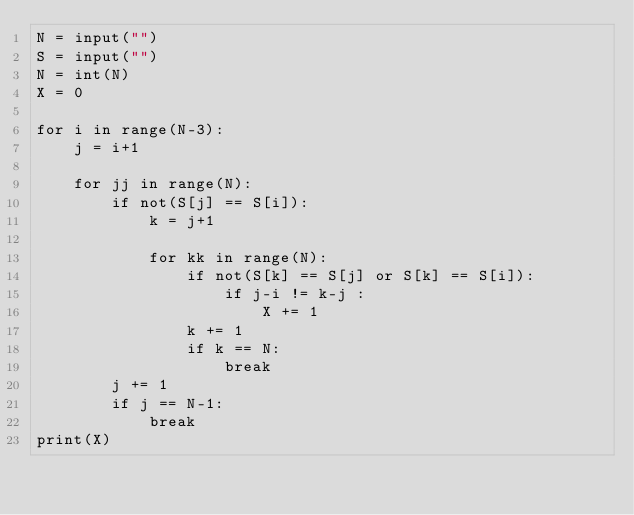<code> <loc_0><loc_0><loc_500><loc_500><_Cython_>N = input("")
S = input("")
N = int(N)
X = 0

for i in range(N-3):
    j = i+1

    for jj in range(N):
        if not(S[j] == S[i]):
            k = j+1

            for kk in range(N):
                if not(S[k] == S[j] or S[k] == S[i]):
                    if j-i != k-j :
                        X += 1
                k += 1
                if k == N:
                    break            
        j += 1
        if j == N-1:
            break
print(X)</code> 